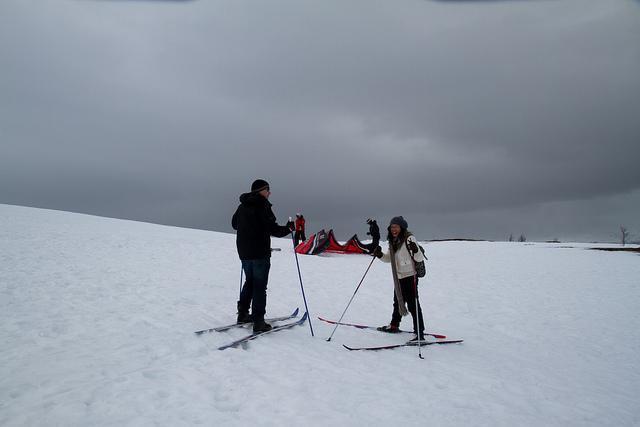How many people can be seen?
Give a very brief answer. 2. 